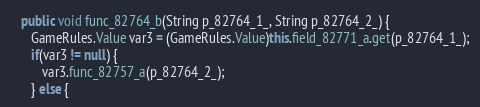<code> <loc_0><loc_0><loc_500><loc_500><_Java_>
   public void func_82764_b(String p_82764_1_, String p_82764_2_) {
      GameRules.Value var3 = (GameRules.Value)this.field_82771_a.get(p_82764_1_);
      if(var3 != null) {
         var3.func_82757_a(p_82764_2_);
      } else {</code> 